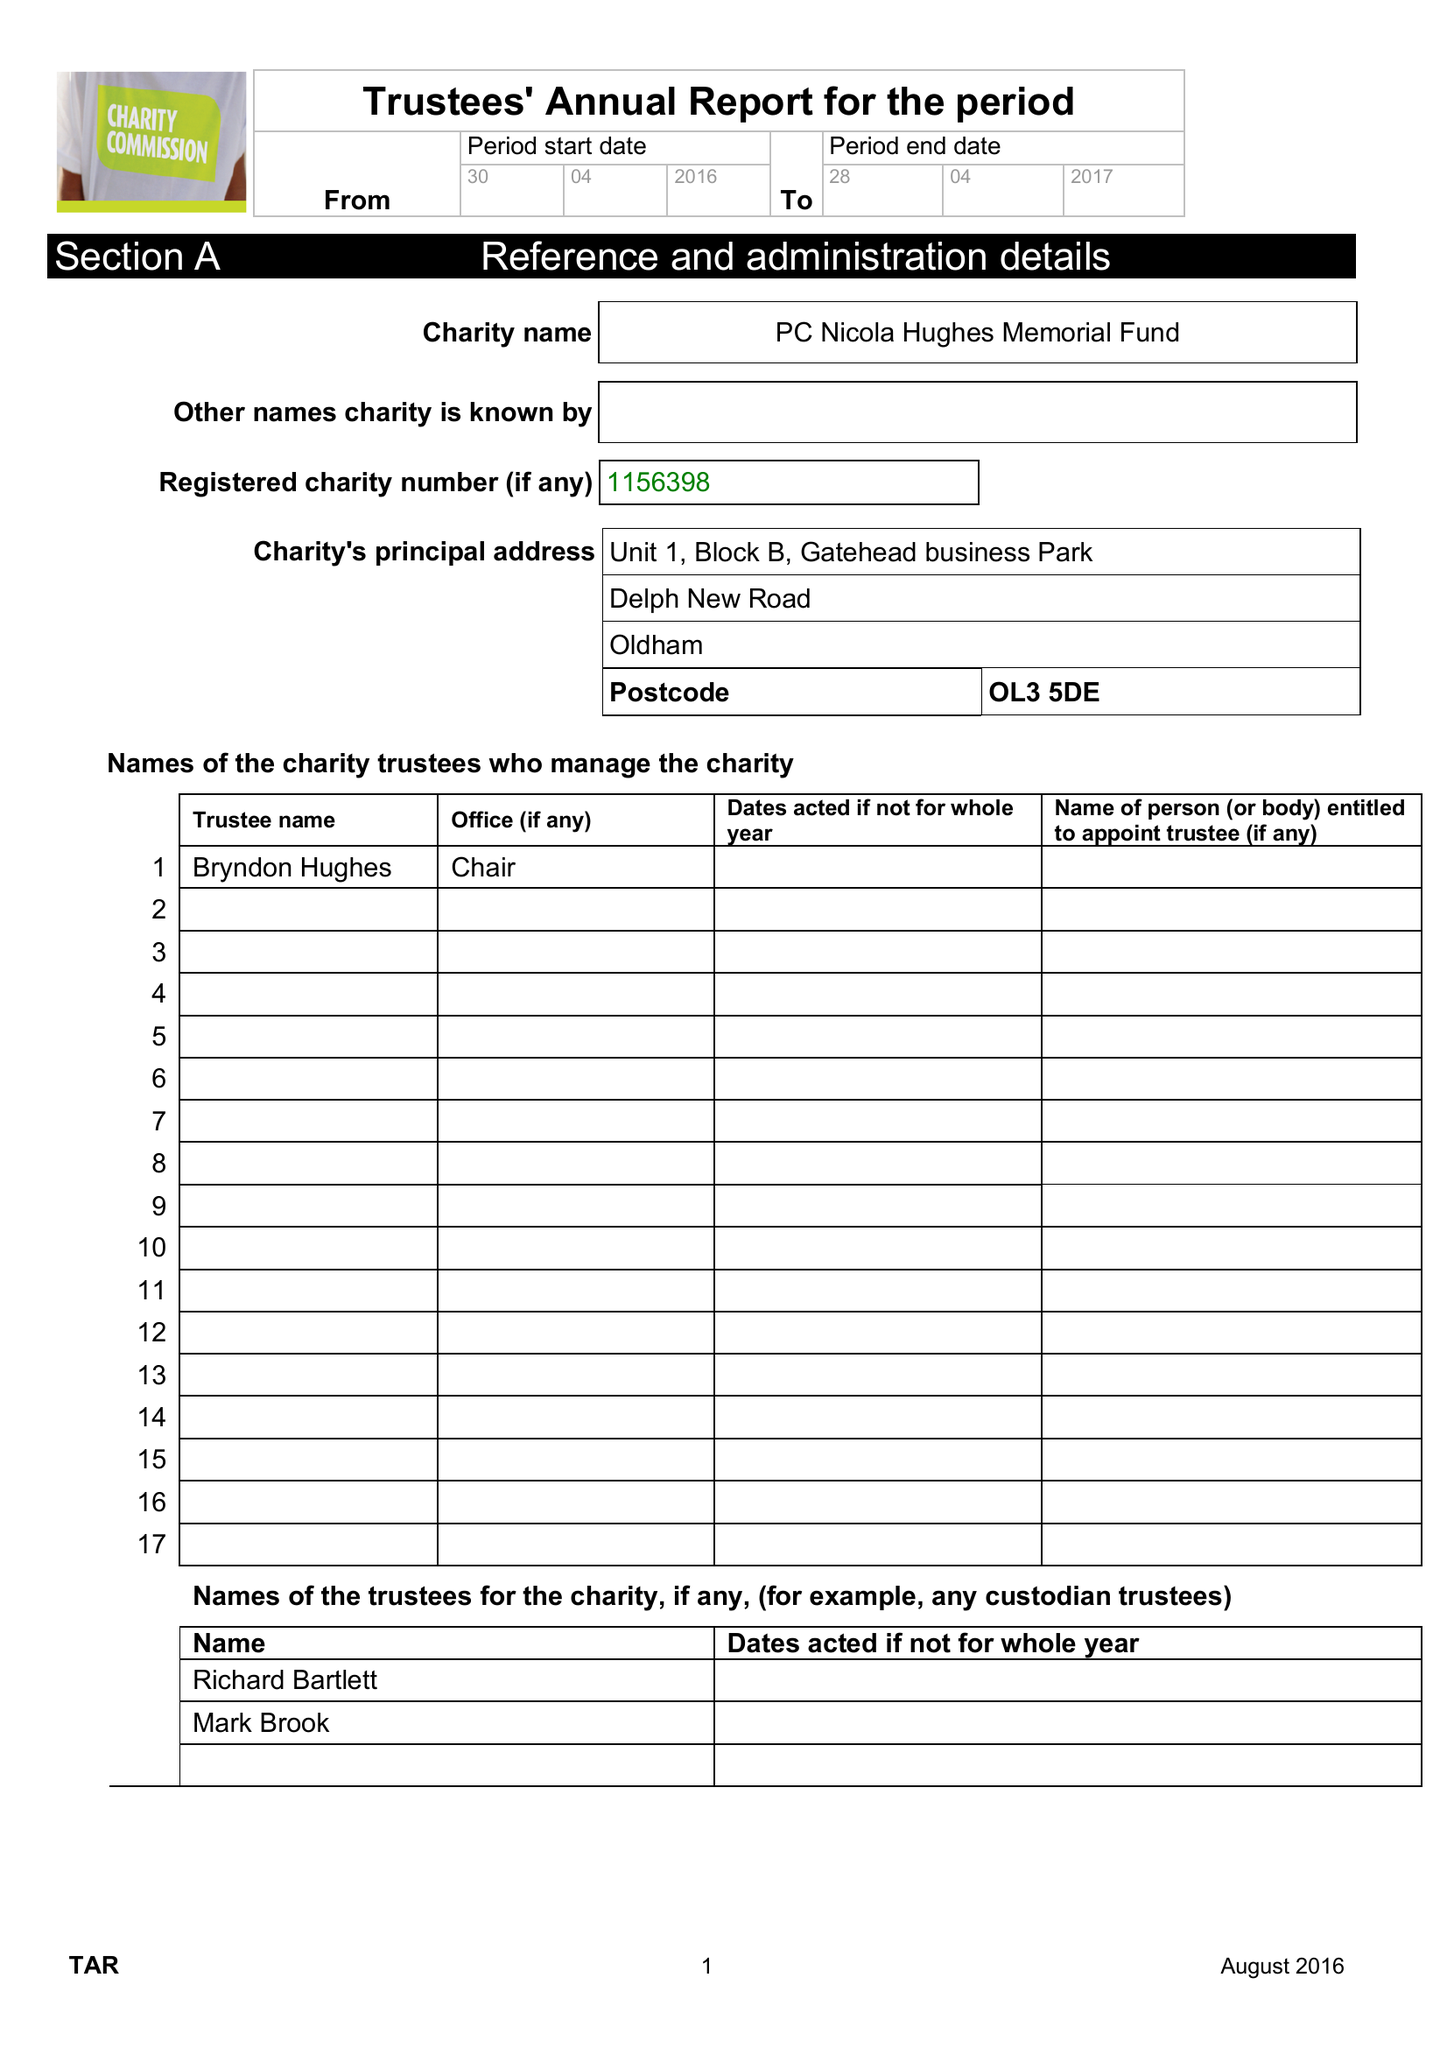What is the value for the report_date?
Answer the question using a single word or phrase. 2017-04-29 